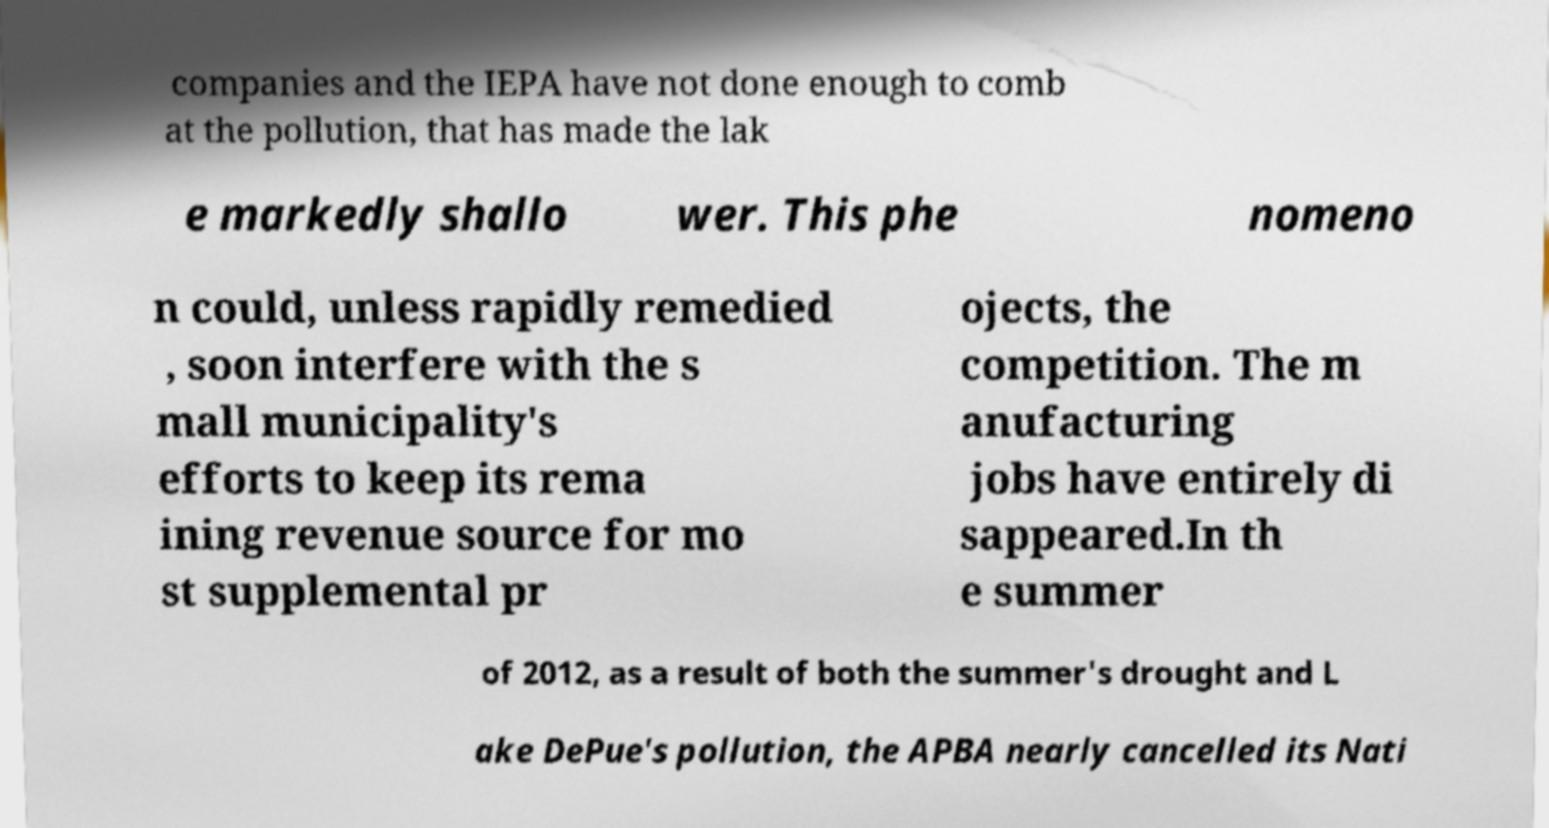For documentation purposes, I need the text within this image transcribed. Could you provide that? companies and the IEPA have not done enough to comb at the pollution, that has made the lak e markedly shallo wer. This phe nomeno n could, unless rapidly remedied , soon interfere with the s mall municipality's efforts to keep its rema ining revenue source for mo st supplemental pr ojects, the competition. The m anufacturing jobs have entirely di sappeared.In th e summer of 2012, as a result of both the summer's drought and L ake DePue's pollution, the APBA nearly cancelled its Nati 